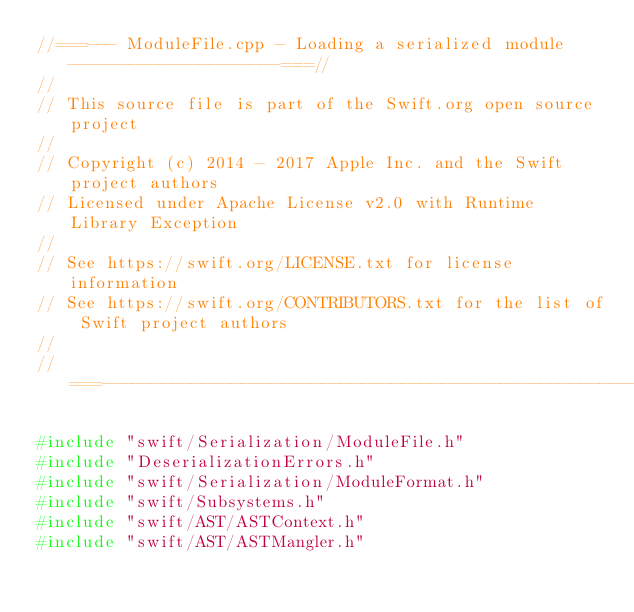<code> <loc_0><loc_0><loc_500><loc_500><_C++_>//===--- ModuleFile.cpp - Loading a serialized module ---------------------===//
//
// This source file is part of the Swift.org open source project
//
// Copyright (c) 2014 - 2017 Apple Inc. and the Swift project authors
// Licensed under Apache License v2.0 with Runtime Library Exception
//
// See https://swift.org/LICENSE.txt for license information
// See https://swift.org/CONTRIBUTORS.txt for the list of Swift project authors
//
//===----------------------------------------------------------------------===//

#include "swift/Serialization/ModuleFile.h"
#include "DeserializationErrors.h"
#include "swift/Serialization/ModuleFormat.h"
#include "swift/Subsystems.h"
#include "swift/AST/ASTContext.h"
#include "swift/AST/ASTMangler.h"</code> 